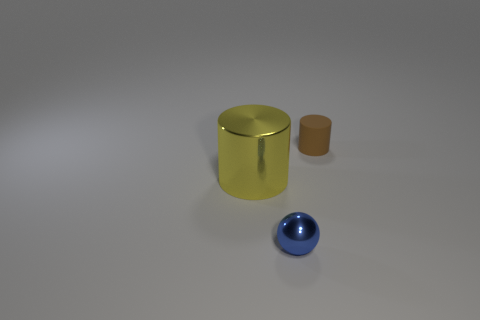Add 2 large green cylinders. How many objects exist? 5 Subtract all cylinders. How many objects are left? 1 Add 2 small cylinders. How many small cylinders exist? 3 Subtract 0 cyan balls. How many objects are left? 3 Subtract all yellow rubber objects. Subtract all tiny spheres. How many objects are left? 2 Add 2 yellow shiny cylinders. How many yellow shiny cylinders are left? 3 